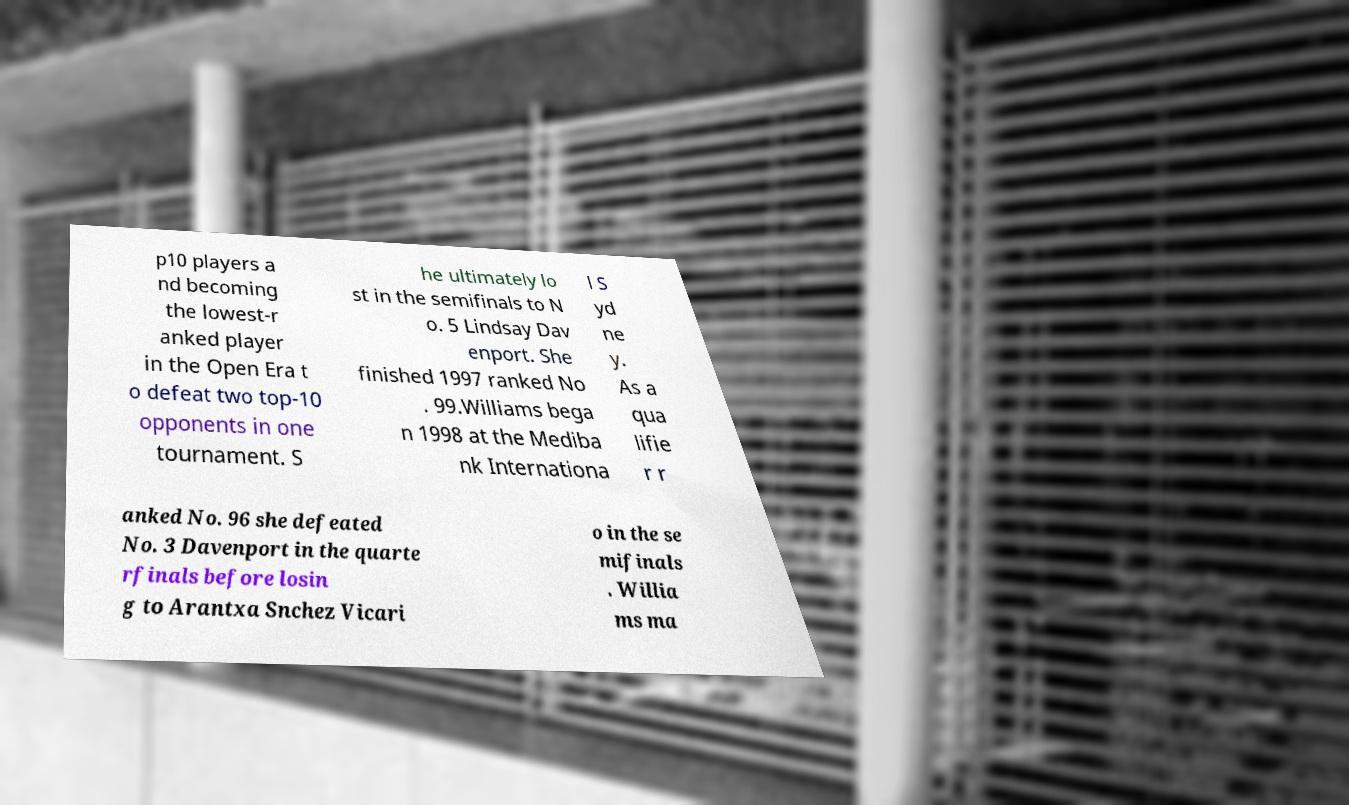I need the written content from this picture converted into text. Can you do that? p10 players a nd becoming the lowest-r anked player in the Open Era t o defeat two top-10 opponents in one tournament. S he ultimately lo st in the semifinals to N o. 5 Lindsay Dav enport. She finished 1997 ranked No . 99.Williams bega n 1998 at the Mediba nk Internationa l S yd ne y. As a qua lifie r r anked No. 96 she defeated No. 3 Davenport in the quarte rfinals before losin g to Arantxa Snchez Vicari o in the se mifinals . Willia ms ma 